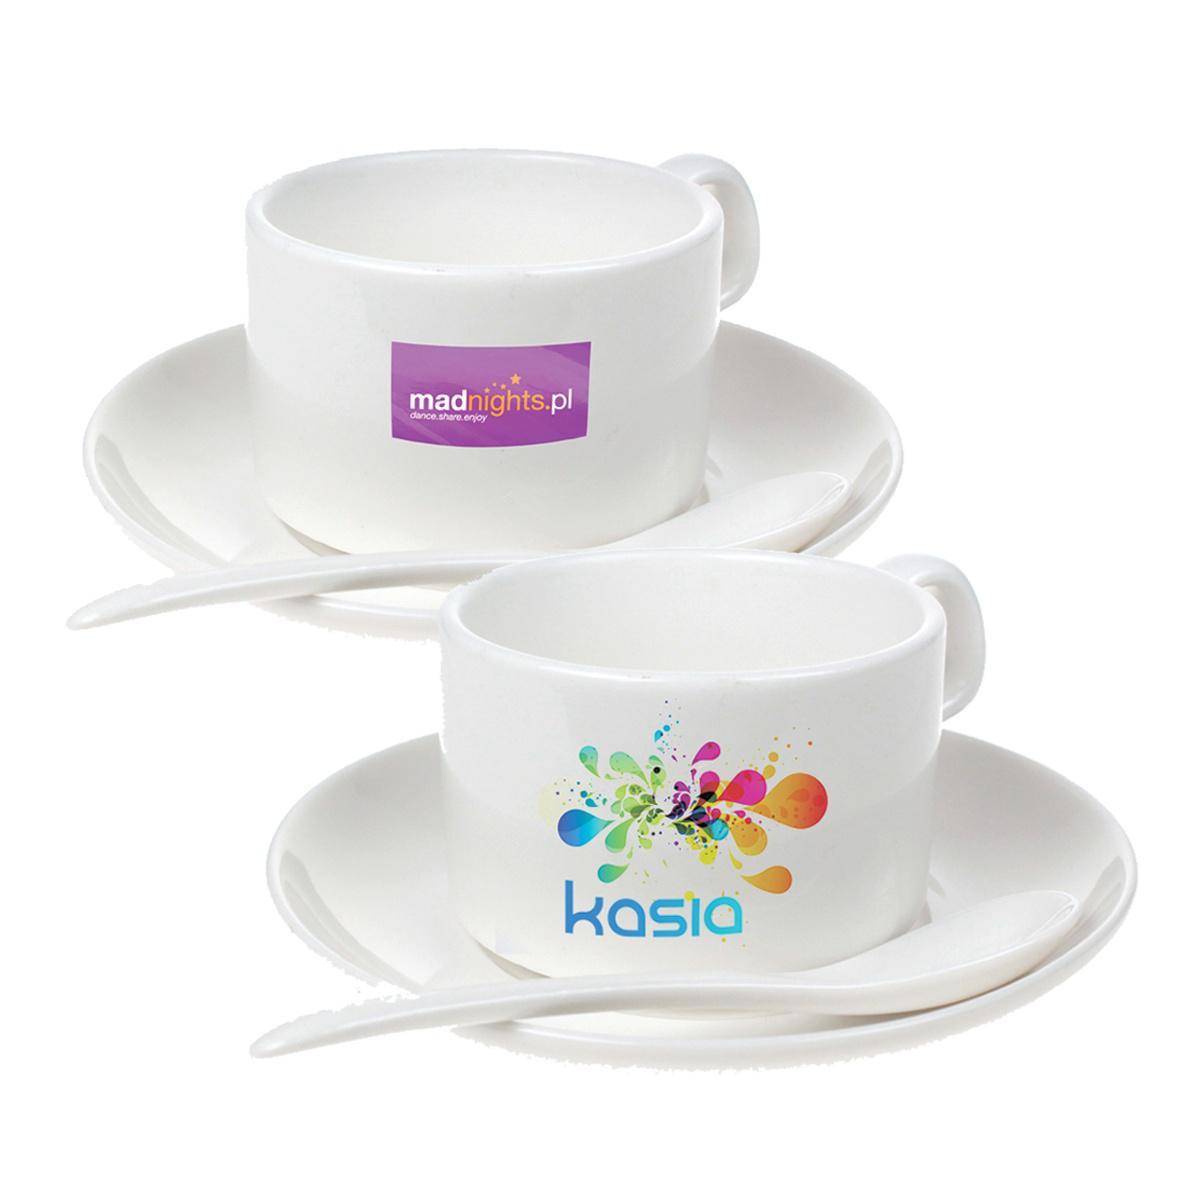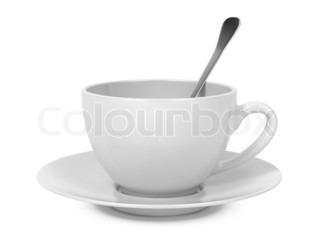The first image is the image on the left, the second image is the image on the right. Analyze the images presented: Is the assertion "A spoon is resting on a saucer near a tea cup." valid? Answer yes or no. Yes. The first image is the image on the left, the second image is the image on the right. Examine the images to the left and right. Is the description "There are three or more tea cups." accurate? Answer yes or no. Yes. 